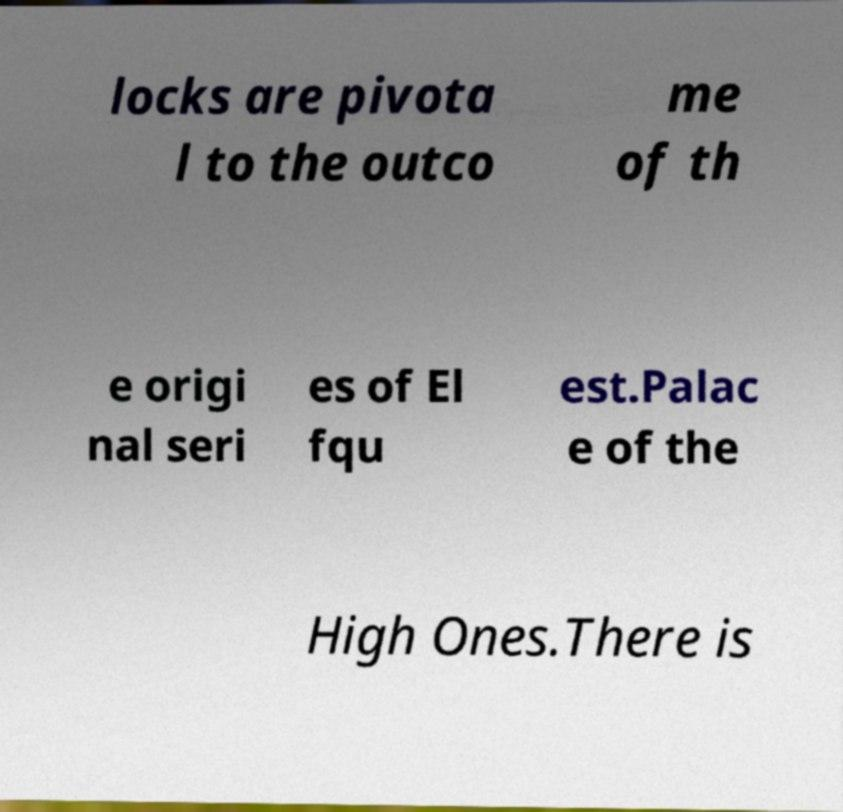For documentation purposes, I need the text within this image transcribed. Could you provide that? locks are pivota l to the outco me of th e origi nal seri es of El fqu est.Palac e of the High Ones.There is 